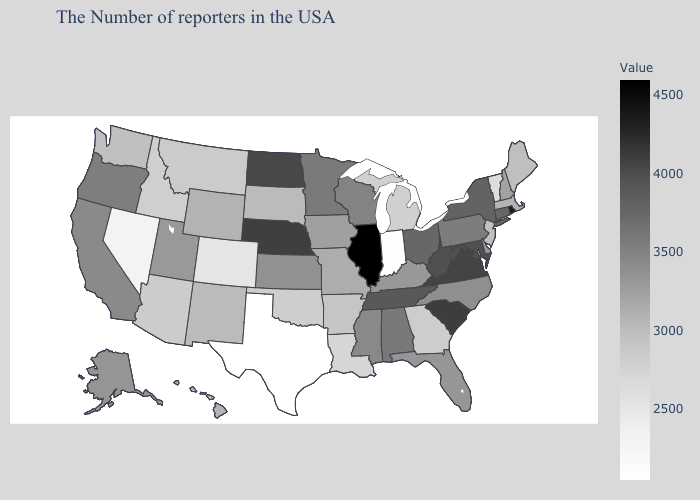Among the states that border Florida , which have the lowest value?
Keep it brief. Georgia. Which states have the lowest value in the USA?
Be succinct. Texas. Which states have the lowest value in the USA?
Give a very brief answer. Texas. Does Illinois have the highest value in the USA?
Concise answer only. Yes. Does the map have missing data?
Be succinct. No. Does Nevada have the lowest value in the West?
Quick response, please. Yes. Is the legend a continuous bar?
Concise answer only. Yes. 